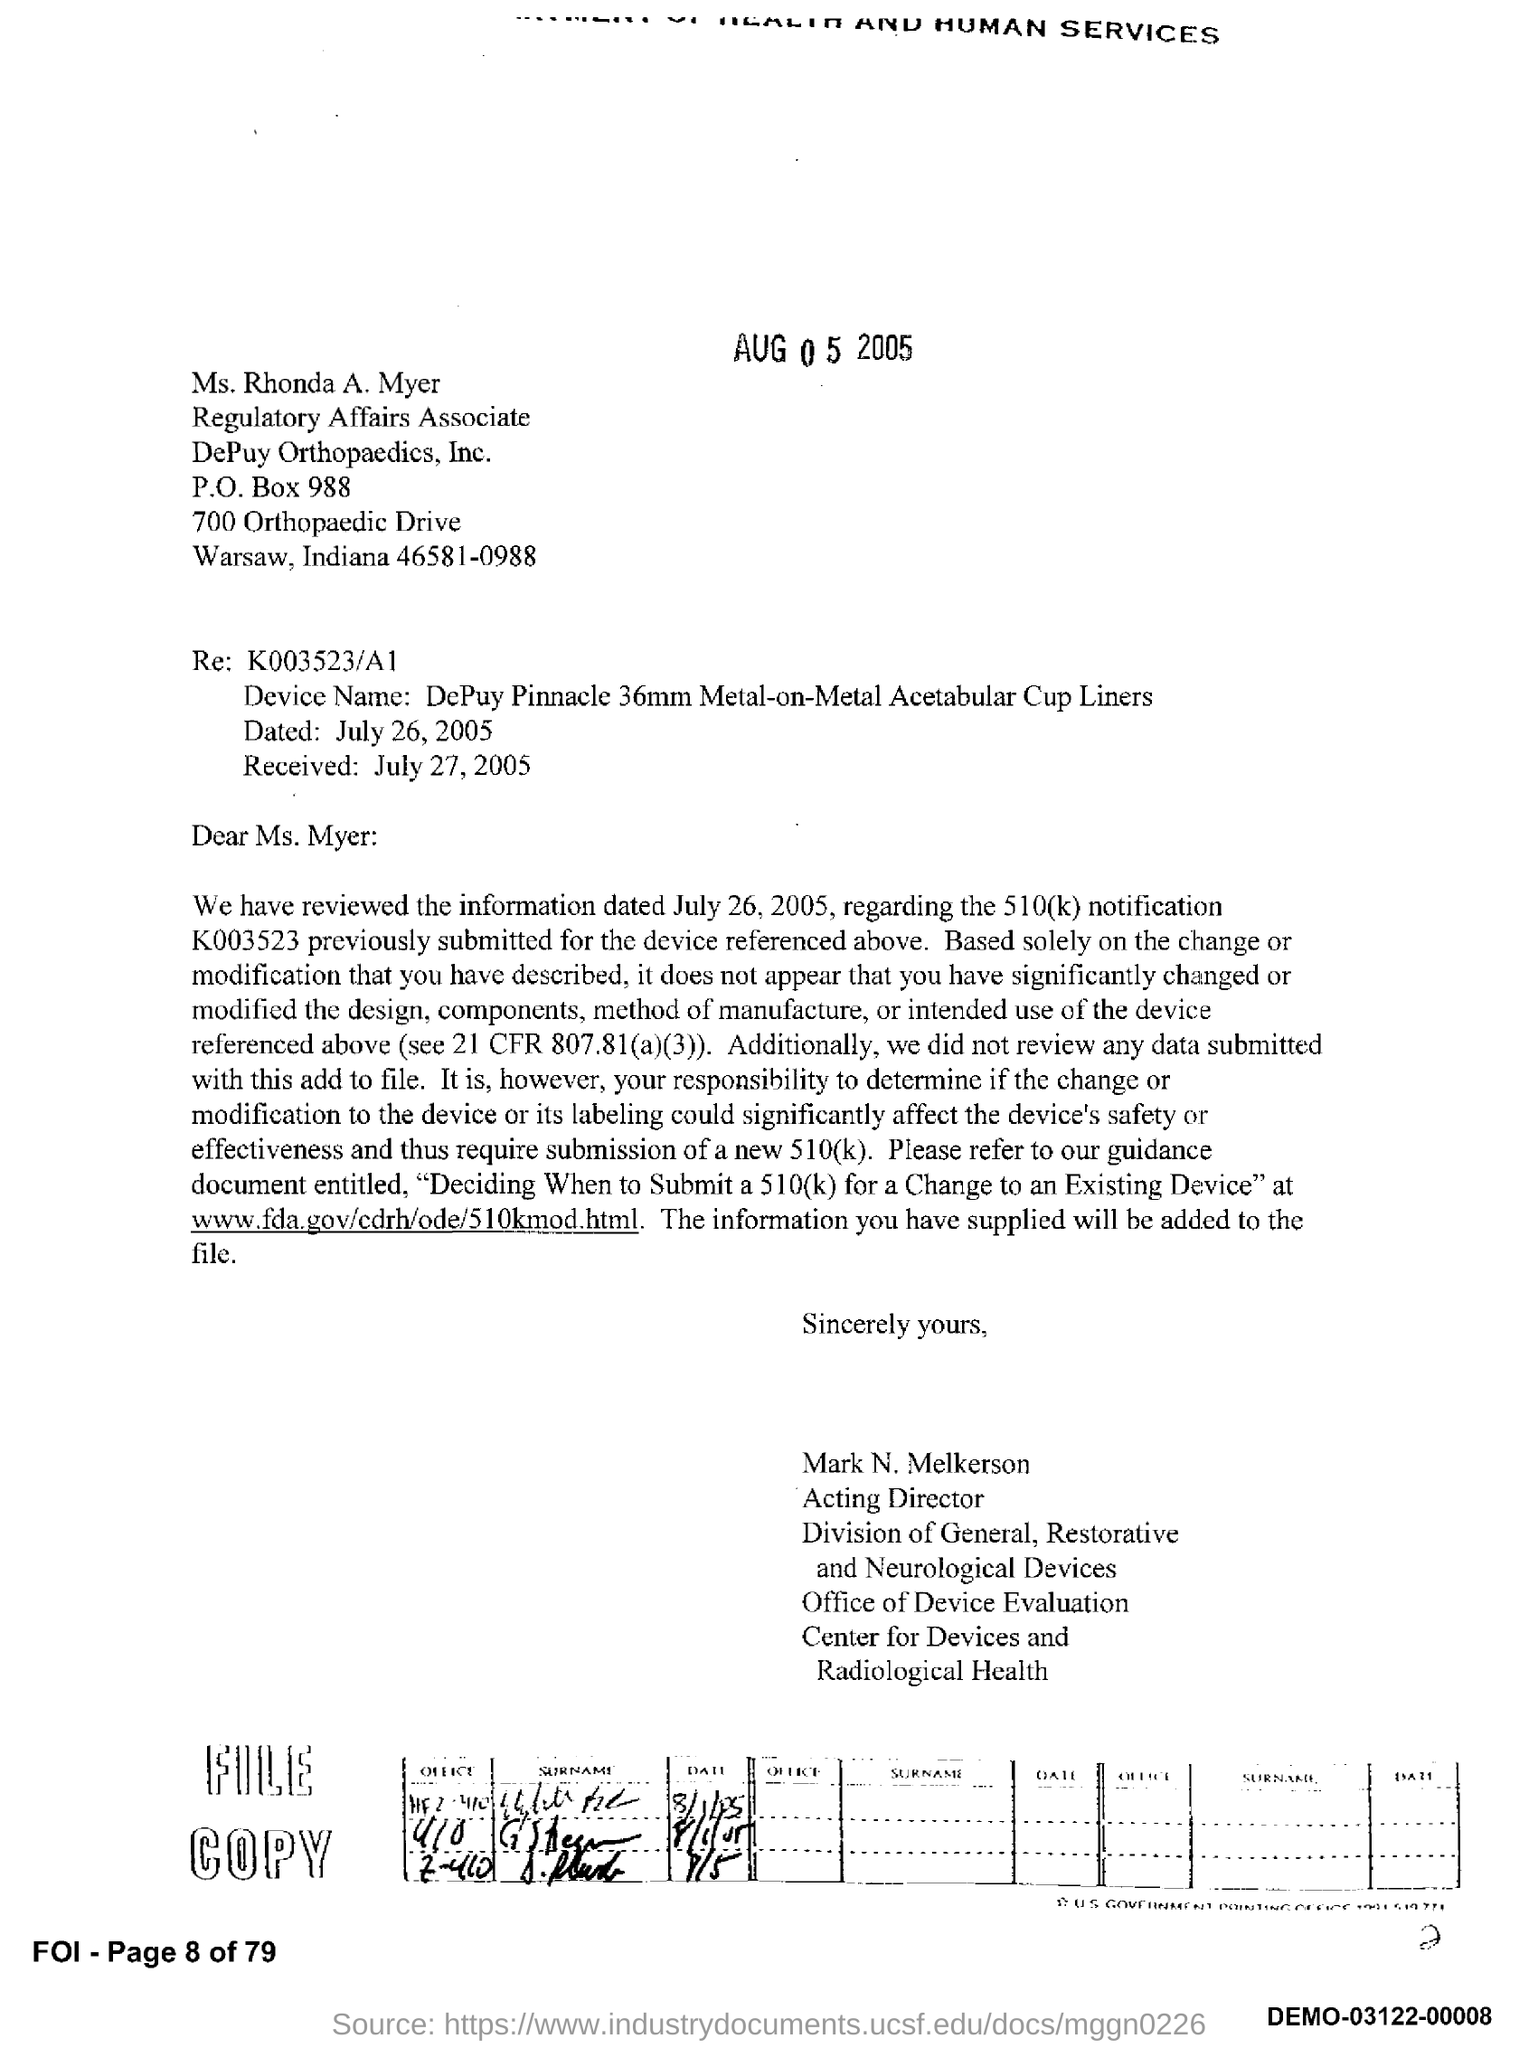Specify some key components in this picture. The PO Box number mentioned in the document is 988. The device named "DePuy Pinnacle 36mm Metal-On-Metal Acetabular Cup Liners" is a specific type of device used in hip replacement surgery. 